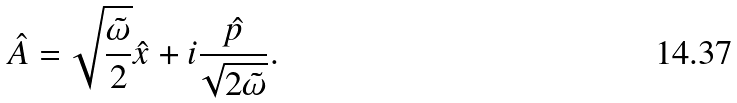Convert formula to latex. <formula><loc_0><loc_0><loc_500><loc_500>\hat { A } = \sqrt { \frac { \tilde { \omega } } { 2 } } \hat { x } + i \frac { \hat { p } } { \sqrt { 2 \tilde { \omega } } } .</formula> 